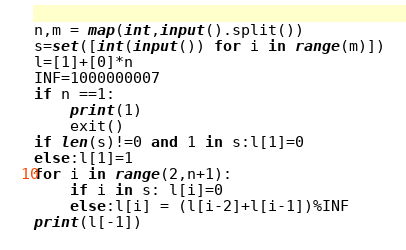Convert code to text. <code><loc_0><loc_0><loc_500><loc_500><_Python_>n,m = map(int,input().split())
s=set([int(input()) for i in range(m)])
l=[1]+[0]*n
INF=1000000007
if n ==1:
    print(1)
    exit()
if len(s)!=0 and 1 in s:l[1]=0
else:l[1]=1
for i in range(2,n+1):
    if i in s: l[i]=0
    else:l[i] = (l[i-2]+l[i-1])%INF
print(l[-1])</code> 